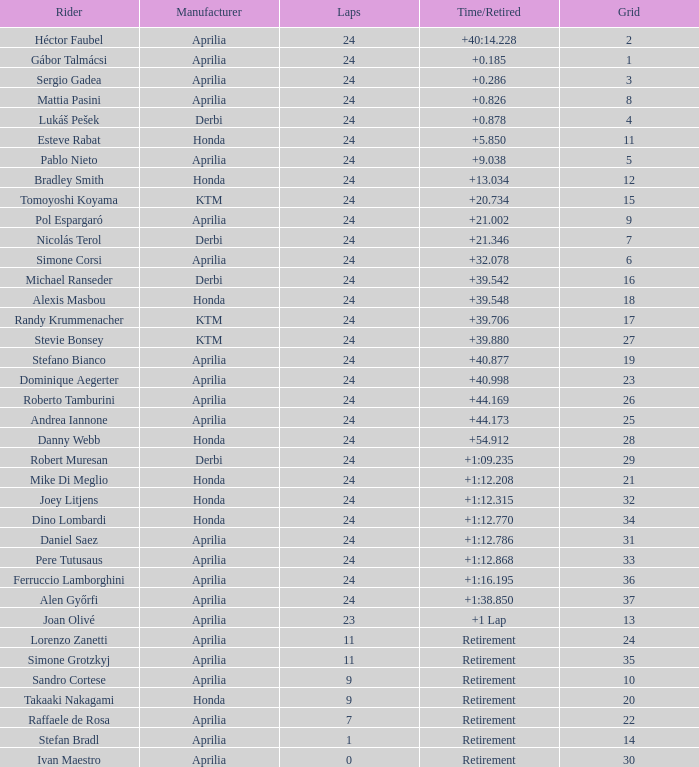What is the time with 10 grids? Retirement. 